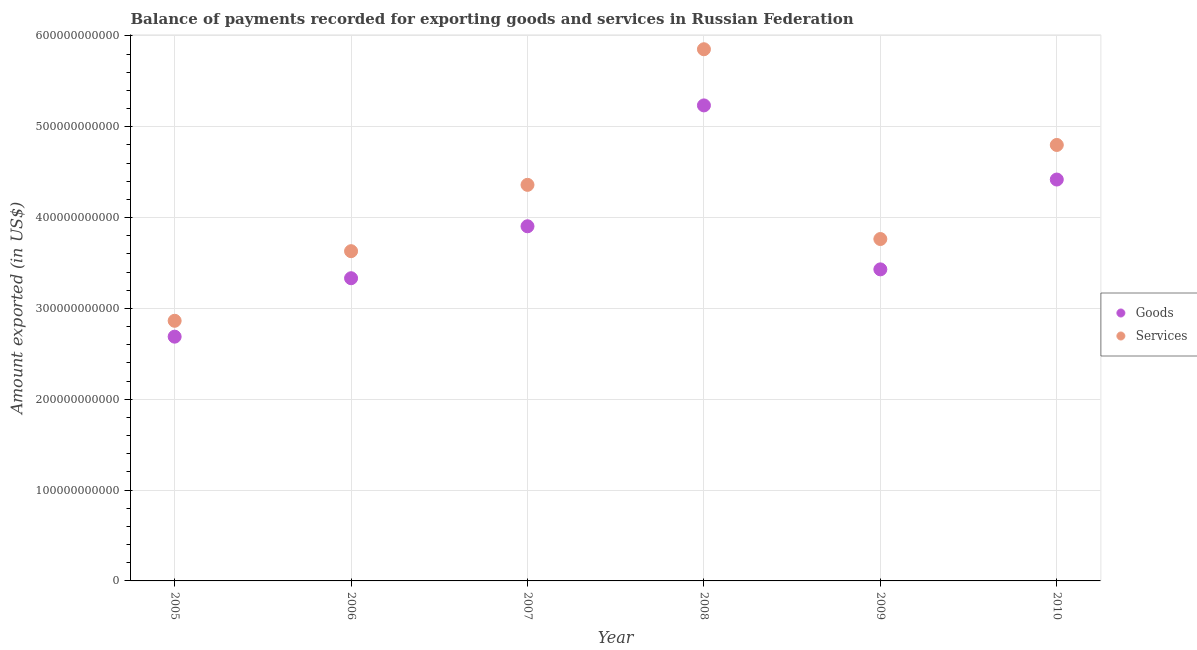What is the amount of services exported in 2010?
Offer a terse response. 4.80e+11. Across all years, what is the maximum amount of goods exported?
Provide a succinct answer. 5.23e+11. Across all years, what is the minimum amount of services exported?
Ensure brevity in your answer.  2.86e+11. In which year was the amount of services exported maximum?
Make the answer very short. 2008. What is the total amount of goods exported in the graph?
Your answer should be compact. 2.30e+12. What is the difference between the amount of goods exported in 2008 and that in 2009?
Ensure brevity in your answer.  1.80e+11. What is the difference between the amount of services exported in 2007 and the amount of goods exported in 2010?
Offer a terse response. -5.86e+09. What is the average amount of goods exported per year?
Your answer should be compact. 3.83e+11. In the year 2007, what is the difference between the amount of goods exported and amount of services exported?
Your answer should be compact. -4.56e+1. In how many years, is the amount of goods exported greater than 520000000000 US$?
Your answer should be very brief. 1. What is the ratio of the amount of services exported in 2006 to that in 2007?
Keep it short and to the point. 0.83. Is the amount of goods exported in 2005 less than that in 2010?
Provide a short and direct response. Yes. What is the difference between the highest and the second highest amount of goods exported?
Make the answer very short. 8.16e+1. What is the difference between the highest and the lowest amount of services exported?
Make the answer very short. 2.99e+11. Is the sum of the amount of goods exported in 2009 and 2010 greater than the maximum amount of services exported across all years?
Offer a very short reply. Yes. Does the amount of services exported monotonically increase over the years?
Ensure brevity in your answer.  No. Is the amount of services exported strictly greater than the amount of goods exported over the years?
Make the answer very short. Yes. How many years are there in the graph?
Ensure brevity in your answer.  6. What is the difference between two consecutive major ticks on the Y-axis?
Your answer should be very brief. 1.00e+11. Does the graph contain grids?
Your answer should be compact. Yes. Where does the legend appear in the graph?
Offer a terse response. Center right. How many legend labels are there?
Offer a terse response. 2. What is the title of the graph?
Give a very brief answer. Balance of payments recorded for exporting goods and services in Russian Federation. What is the label or title of the Y-axis?
Provide a succinct answer. Amount exported (in US$). What is the Amount exported (in US$) of Goods in 2005?
Provide a succinct answer. 2.69e+11. What is the Amount exported (in US$) in Services in 2005?
Provide a short and direct response. 2.86e+11. What is the Amount exported (in US$) of Goods in 2006?
Provide a short and direct response. 3.33e+11. What is the Amount exported (in US$) of Services in 2006?
Your answer should be compact. 3.63e+11. What is the Amount exported (in US$) in Goods in 2007?
Make the answer very short. 3.90e+11. What is the Amount exported (in US$) of Services in 2007?
Make the answer very short. 4.36e+11. What is the Amount exported (in US$) in Goods in 2008?
Ensure brevity in your answer.  5.23e+11. What is the Amount exported (in US$) of Services in 2008?
Offer a terse response. 5.85e+11. What is the Amount exported (in US$) in Goods in 2009?
Give a very brief answer. 3.43e+11. What is the Amount exported (in US$) of Services in 2009?
Your answer should be compact. 3.76e+11. What is the Amount exported (in US$) of Goods in 2010?
Your response must be concise. 4.42e+11. What is the Amount exported (in US$) of Services in 2010?
Your answer should be very brief. 4.80e+11. Across all years, what is the maximum Amount exported (in US$) of Goods?
Offer a very short reply. 5.23e+11. Across all years, what is the maximum Amount exported (in US$) in Services?
Your answer should be very brief. 5.85e+11. Across all years, what is the minimum Amount exported (in US$) in Goods?
Your response must be concise. 2.69e+11. Across all years, what is the minimum Amount exported (in US$) of Services?
Ensure brevity in your answer.  2.86e+11. What is the total Amount exported (in US$) in Goods in the graph?
Offer a very short reply. 2.30e+12. What is the total Amount exported (in US$) in Services in the graph?
Provide a succinct answer. 2.53e+12. What is the difference between the Amount exported (in US$) in Goods in 2005 and that in 2006?
Ensure brevity in your answer.  -6.43e+1. What is the difference between the Amount exported (in US$) in Services in 2005 and that in 2006?
Provide a succinct answer. -7.66e+1. What is the difference between the Amount exported (in US$) of Goods in 2005 and that in 2007?
Your answer should be very brief. -1.22e+11. What is the difference between the Amount exported (in US$) in Services in 2005 and that in 2007?
Your answer should be compact. -1.50e+11. What is the difference between the Amount exported (in US$) of Goods in 2005 and that in 2008?
Provide a succinct answer. -2.55e+11. What is the difference between the Amount exported (in US$) in Services in 2005 and that in 2008?
Your response must be concise. -2.99e+11. What is the difference between the Amount exported (in US$) in Goods in 2005 and that in 2009?
Ensure brevity in your answer.  -7.41e+1. What is the difference between the Amount exported (in US$) of Services in 2005 and that in 2009?
Ensure brevity in your answer.  -9.00e+1. What is the difference between the Amount exported (in US$) of Goods in 2005 and that in 2010?
Offer a terse response. -1.73e+11. What is the difference between the Amount exported (in US$) of Services in 2005 and that in 2010?
Give a very brief answer. -1.94e+11. What is the difference between the Amount exported (in US$) of Goods in 2006 and that in 2007?
Provide a succinct answer. -5.72e+1. What is the difference between the Amount exported (in US$) in Services in 2006 and that in 2007?
Your answer should be very brief. -7.30e+1. What is the difference between the Amount exported (in US$) of Goods in 2006 and that in 2008?
Provide a succinct answer. -1.90e+11. What is the difference between the Amount exported (in US$) of Services in 2006 and that in 2008?
Your answer should be very brief. -2.22e+11. What is the difference between the Amount exported (in US$) of Goods in 2006 and that in 2009?
Make the answer very short. -9.75e+09. What is the difference between the Amount exported (in US$) of Services in 2006 and that in 2009?
Provide a succinct answer. -1.34e+1. What is the difference between the Amount exported (in US$) of Goods in 2006 and that in 2010?
Your answer should be compact. -1.09e+11. What is the difference between the Amount exported (in US$) in Services in 2006 and that in 2010?
Keep it short and to the point. -1.17e+11. What is the difference between the Amount exported (in US$) of Goods in 2007 and that in 2008?
Offer a very short reply. -1.33e+11. What is the difference between the Amount exported (in US$) in Services in 2007 and that in 2008?
Give a very brief answer. -1.49e+11. What is the difference between the Amount exported (in US$) of Goods in 2007 and that in 2009?
Offer a very short reply. 4.74e+1. What is the difference between the Amount exported (in US$) in Services in 2007 and that in 2009?
Provide a succinct answer. 5.96e+1. What is the difference between the Amount exported (in US$) in Goods in 2007 and that in 2010?
Ensure brevity in your answer.  -5.14e+1. What is the difference between the Amount exported (in US$) in Services in 2007 and that in 2010?
Your response must be concise. -4.39e+1. What is the difference between the Amount exported (in US$) in Goods in 2008 and that in 2009?
Offer a terse response. 1.80e+11. What is the difference between the Amount exported (in US$) of Services in 2008 and that in 2009?
Offer a terse response. 2.09e+11. What is the difference between the Amount exported (in US$) in Goods in 2008 and that in 2010?
Your answer should be compact. 8.16e+1. What is the difference between the Amount exported (in US$) in Services in 2008 and that in 2010?
Offer a very short reply. 1.05e+11. What is the difference between the Amount exported (in US$) in Goods in 2009 and that in 2010?
Provide a succinct answer. -9.89e+1. What is the difference between the Amount exported (in US$) in Services in 2009 and that in 2010?
Offer a very short reply. -1.04e+11. What is the difference between the Amount exported (in US$) in Goods in 2005 and the Amount exported (in US$) in Services in 2006?
Provide a succinct answer. -9.41e+1. What is the difference between the Amount exported (in US$) of Goods in 2005 and the Amount exported (in US$) of Services in 2007?
Your response must be concise. -1.67e+11. What is the difference between the Amount exported (in US$) in Goods in 2005 and the Amount exported (in US$) in Services in 2008?
Offer a terse response. -3.16e+11. What is the difference between the Amount exported (in US$) of Goods in 2005 and the Amount exported (in US$) of Services in 2009?
Make the answer very short. -1.07e+11. What is the difference between the Amount exported (in US$) of Goods in 2005 and the Amount exported (in US$) of Services in 2010?
Give a very brief answer. -2.11e+11. What is the difference between the Amount exported (in US$) of Goods in 2006 and the Amount exported (in US$) of Services in 2007?
Provide a succinct answer. -1.03e+11. What is the difference between the Amount exported (in US$) in Goods in 2006 and the Amount exported (in US$) in Services in 2008?
Your response must be concise. -2.52e+11. What is the difference between the Amount exported (in US$) in Goods in 2006 and the Amount exported (in US$) in Services in 2009?
Your response must be concise. -4.32e+1. What is the difference between the Amount exported (in US$) in Goods in 2006 and the Amount exported (in US$) in Services in 2010?
Your response must be concise. -1.47e+11. What is the difference between the Amount exported (in US$) in Goods in 2007 and the Amount exported (in US$) in Services in 2008?
Your answer should be compact. -1.95e+11. What is the difference between the Amount exported (in US$) of Goods in 2007 and the Amount exported (in US$) of Services in 2009?
Offer a terse response. 1.40e+1. What is the difference between the Amount exported (in US$) in Goods in 2007 and the Amount exported (in US$) in Services in 2010?
Offer a very short reply. -8.95e+1. What is the difference between the Amount exported (in US$) of Goods in 2008 and the Amount exported (in US$) of Services in 2009?
Keep it short and to the point. 1.47e+11. What is the difference between the Amount exported (in US$) in Goods in 2008 and the Amount exported (in US$) in Services in 2010?
Provide a succinct answer. 4.35e+1. What is the difference between the Amount exported (in US$) in Goods in 2009 and the Amount exported (in US$) in Services in 2010?
Provide a short and direct response. -1.37e+11. What is the average Amount exported (in US$) of Goods per year?
Ensure brevity in your answer.  3.83e+11. What is the average Amount exported (in US$) of Services per year?
Ensure brevity in your answer.  4.21e+11. In the year 2005, what is the difference between the Amount exported (in US$) in Goods and Amount exported (in US$) in Services?
Offer a terse response. -1.75e+1. In the year 2006, what is the difference between the Amount exported (in US$) in Goods and Amount exported (in US$) in Services?
Your answer should be very brief. -2.98e+1. In the year 2007, what is the difference between the Amount exported (in US$) in Goods and Amount exported (in US$) in Services?
Provide a succinct answer. -4.56e+1. In the year 2008, what is the difference between the Amount exported (in US$) in Goods and Amount exported (in US$) in Services?
Give a very brief answer. -6.18e+1. In the year 2009, what is the difference between the Amount exported (in US$) in Goods and Amount exported (in US$) in Services?
Your answer should be very brief. -3.34e+1. In the year 2010, what is the difference between the Amount exported (in US$) of Goods and Amount exported (in US$) of Services?
Your answer should be compact. -3.81e+1. What is the ratio of the Amount exported (in US$) in Goods in 2005 to that in 2006?
Offer a terse response. 0.81. What is the ratio of the Amount exported (in US$) of Services in 2005 to that in 2006?
Give a very brief answer. 0.79. What is the ratio of the Amount exported (in US$) in Goods in 2005 to that in 2007?
Keep it short and to the point. 0.69. What is the ratio of the Amount exported (in US$) of Services in 2005 to that in 2007?
Offer a terse response. 0.66. What is the ratio of the Amount exported (in US$) of Goods in 2005 to that in 2008?
Offer a terse response. 0.51. What is the ratio of the Amount exported (in US$) in Services in 2005 to that in 2008?
Your answer should be compact. 0.49. What is the ratio of the Amount exported (in US$) of Goods in 2005 to that in 2009?
Your response must be concise. 0.78. What is the ratio of the Amount exported (in US$) in Services in 2005 to that in 2009?
Give a very brief answer. 0.76. What is the ratio of the Amount exported (in US$) in Goods in 2005 to that in 2010?
Your answer should be very brief. 0.61. What is the ratio of the Amount exported (in US$) of Services in 2005 to that in 2010?
Ensure brevity in your answer.  0.6. What is the ratio of the Amount exported (in US$) in Goods in 2006 to that in 2007?
Provide a short and direct response. 0.85. What is the ratio of the Amount exported (in US$) in Services in 2006 to that in 2007?
Provide a short and direct response. 0.83. What is the ratio of the Amount exported (in US$) of Goods in 2006 to that in 2008?
Keep it short and to the point. 0.64. What is the ratio of the Amount exported (in US$) in Services in 2006 to that in 2008?
Offer a very short reply. 0.62. What is the ratio of the Amount exported (in US$) in Goods in 2006 to that in 2009?
Provide a short and direct response. 0.97. What is the ratio of the Amount exported (in US$) in Services in 2006 to that in 2009?
Your answer should be very brief. 0.96. What is the ratio of the Amount exported (in US$) of Goods in 2006 to that in 2010?
Offer a very short reply. 0.75. What is the ratio of the Amount exported (in US$) of Services in 2006 to that in 2010?
Ensure brevity in your answer.  0.76. What is the ratio of the Amount exported (in US$) of Goods in 2007 to that in 2008?
Provide a succinct answer. 0.75. What is the ratio of the Amount exported (in US$) in Services in 2007 to that in 2008?
Ensure brevity in your answer.  0.74. What is the ratio of the Amount exported (in US$) in Goods in 2007 to that in 2009?
Your answer should be very brief. 1.14. What is the ratio of the Amount exported (in US$) of Services in 2007 to that in 2009?
Your answer should be very brief. 1.16. What is the ratio of the Amount exported (in US$) in Goods in 2007 to that in 2010?
Your answer should be very brief. 0.88. What is the ratio of the Amount exported (in US$) of Services in 2007 to that in 2010?
Your response must be concise. 0.91. What is the ratio of the Amount exported (in US$) of Goods in 2008 to that in 2009?
Offer a terse response. 1.53. What is the ratio of the Amount exported (in US$) of Services in 2008 to that in 2009?
Keep it short and to the point. 1.56. What is the ratio of the Amount exported (in US$) of Goods in 2008 to that in 2010?
Offer a very short reply. 1.18. What is the ratio of the Amount exported (in US$) in Services in 2008 to that in 2010?
Your answer should be very brief. 1.22. What is the ratio of the Amount exported (in US$) of Goods in 2009 to that in 2010?
Give a very brief answer. 0.78. What is the ratio of the Amount exported (in US$) in Services in 2009 to that in 2010?
Provide a short and direct response. 0.78. What is the difference between the highest and the second highest Amount exported (in US$) in Goods?
Make the answer very short. 8.16e+1. What is the difference between the highest and the second highest Amount exported (in US$) of Services?
Offer a terse response. 1.05e+11. What is the difference between the highest and the lowest Amount exported (in US$) of Goods?
Your answer should be compact. 2.55e+11. What is the difference between the highest and the lowest Amount exported (in US$) in Services?
Keep it short and to the point. 2.99e+11. 